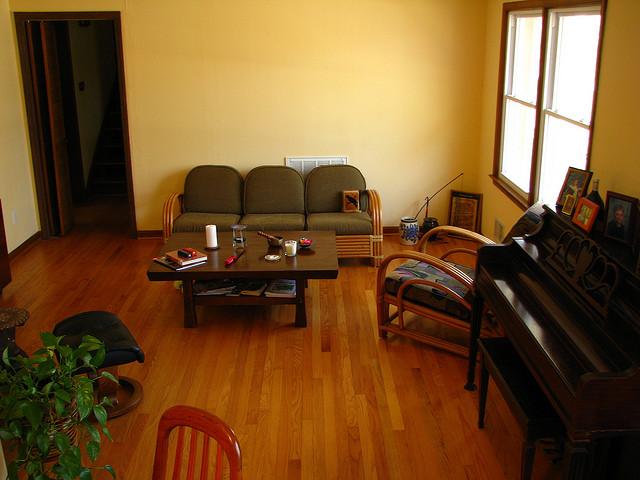Is it daytime?
Give a very brief answer. Yes. Is there anyone in the room?
Be succinct. No. Is the tree real?
Give a very brief answer. No. 